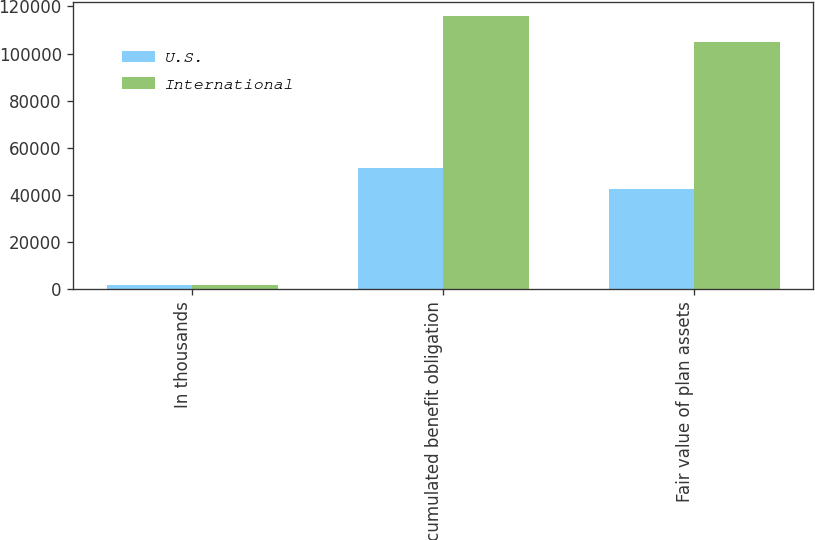Convert chart to OTSL. <chart><loc_0><loc_0><loc_500><loc_500><stacked_bar_chart><ecel><fcel>In thousands<fcel>Accumulated benefit obligation<fcel>Fair value of plan assets<nl><fcel>U.S.<fcel>2012<fcel>51428<fcel>42403<nl><fcel>International<fcel>2012<fcel>115885<fcel>104797<nl></chart> 